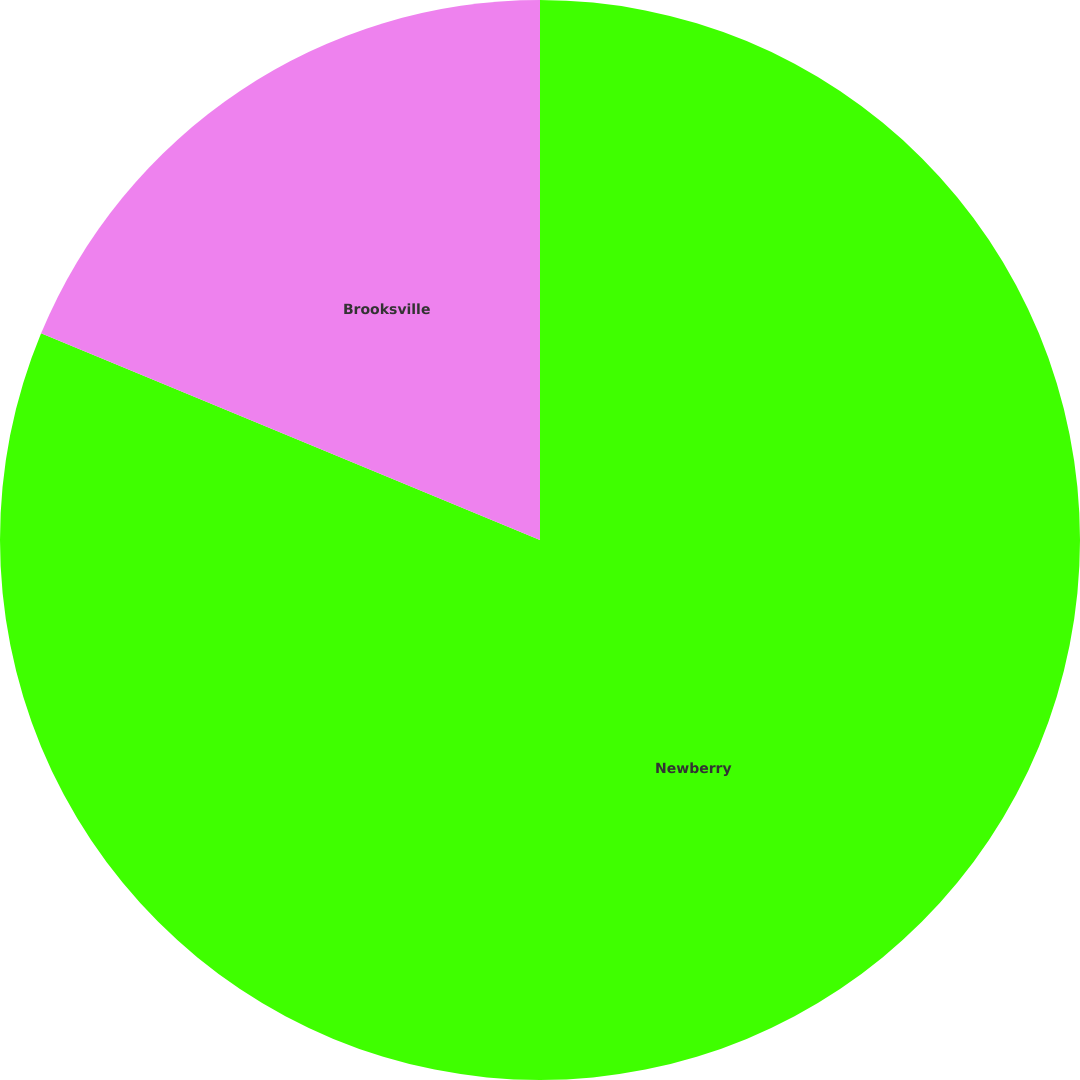Convert chart to OTSL. <chart><loc_0><loc_0><loc_500><loc_500><pie_chart><fcel>Newberry<fcel>Brooksville<nl><fcel>81.25%<fcel>18.75%<nl></chart> 